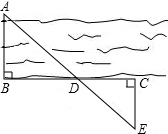Why does using triangle congruence and the Pythagorean theorem help in real-world measures such as estimating the width of a river? Using triangle congruence and the Pythagorean theorem in scenarios like measuring the width of a river provides accurate and practical solutions. Triangle congruence ensures that two triangles have equal angles and sides, offering precise relationships between different parts of a geometric setup. The Pythagorean theorem helps calculate distances indirectly, particularly useful where direct measurement is challenging. Together, they form a robust toolkit for tackling real-world measurement challenges efficiently. 